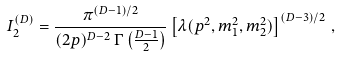<formula> <loc_0><loc_0><loc_500><loc_500>I _ { 2 } ^ { ( D ) } = \frac { \pi ^ { ( D - 1 ) / 2 } } { ( 2 p ) ^ { D - 2 } \, \Gamma \left ( \frac { D - 1 } { 2 } \right ) } \left [ \lambda ( p ^ { 2 } , m _ { 1 } ^ { 2 } , m _ { 2 } ^ { 2 } ) \right ] ^ { ( D - 3 ) / 2 } \, ,</formula> 